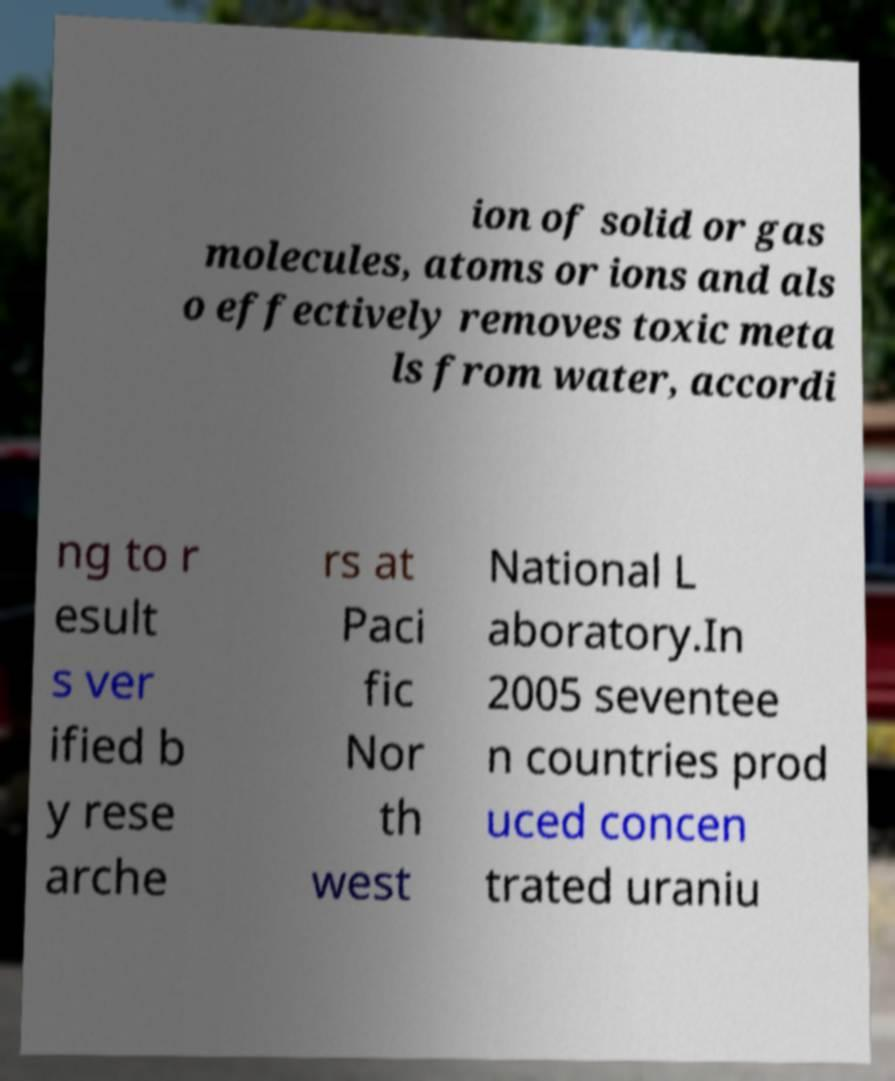Please identify and transcribe the text found in this image. ion of solid or gas molecules, atoms or ions and als o effectively removes toxic meta ls from water, accordi ng to r esult s ver ified b y rese arche rs at Paci fic Nor th west National L aboratory.In 2005 seventee n countries prod uced concen trated uraniu 